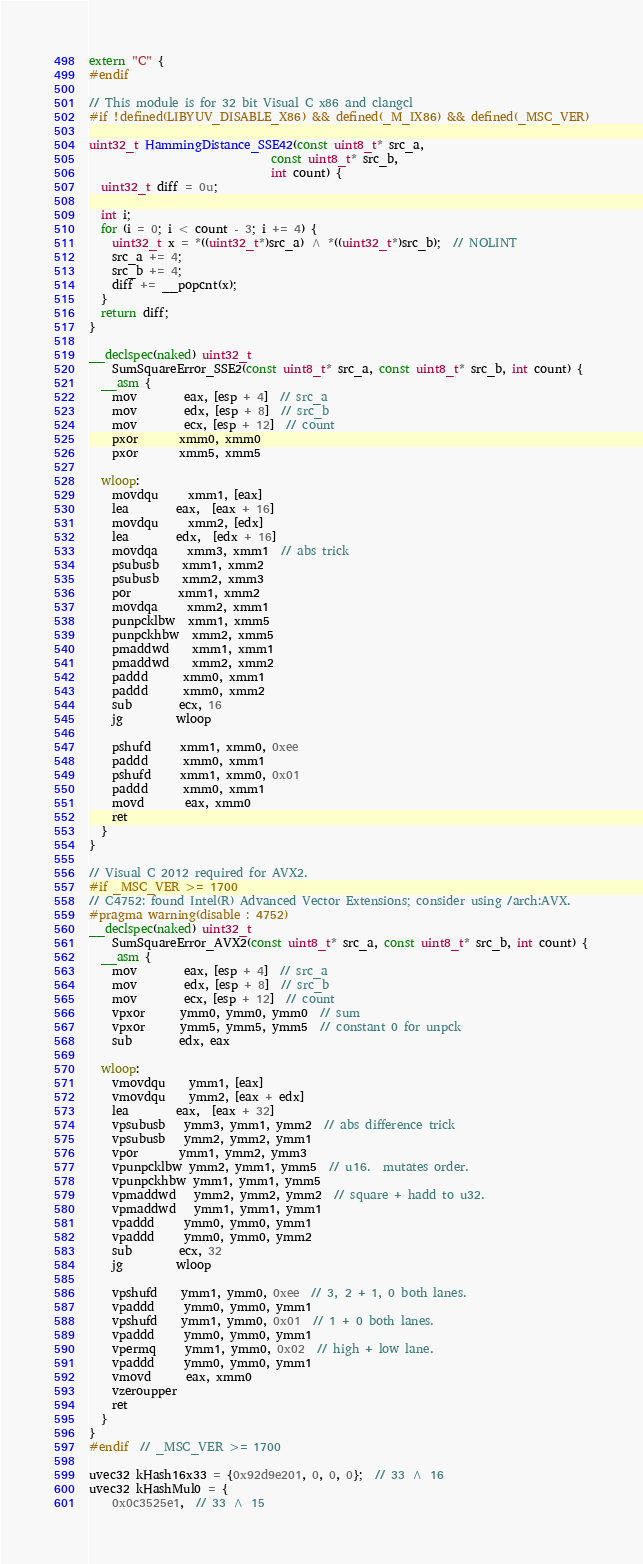Convert code to text. <code><loc_0><loc_0><loc_500><loc_500><_C_>extern "C" {
#endif

// This module is for 32 bit Visual C x86 and clangcl
#if !defined(LIBYUV_DISABLE_X86) && defined(_M_IX86) && defined(_MSC_VER)

uint32_t HammingDistance_SSE42(const uint8_t* src_a,
                               const uint8_t* src_b,
                               int count) {
  uint32_t diff = 0u;

  int i;
  for (i = 0; i < count - 3; i += 4) {
    uint32_t x = *((uint32_t*)src_a) ^ *((uint32_t*)src_b);  // NOLINT
    src_a += 4;
    src_b += 4;
    diff += __popcnt(x);
  }
  return diff;
}

__declspec(naked) uint32_t
    SumSquareError_SSE2(const uint8_t* src_a, const uint8_t* src_b, int count) {
  __asm {
    mov        eax, [esp + 4]  // src_a
    mov        edx, [esp + 8]  // src_b
    mov        ecx, [esp + 12]  // count
    pxor       xmm0, xmm0
    pxor       xmm5, xmm5

  wloop:
    movdqu     xmm1, [eax]
    lea        eax,  [eax + 16]
    movdqu     xmm2, [edx]
    lea        edx,  [edx + 16]
    movdqa     xmm3, xmm1  // abs trick
    psubusb    xmm1, xmm2
    psubusb    xmm2, xmm3
    por        xmm1, xmm2
    movdqa     xmm2, xmm1
    punpcklbw  xmm1, xmm5
    punpckhbw  xmm2, xmm5
    pmaddwd    xmm1, xmm1
    pmaddwd    xmm2, xmm2
    paddd      xmm0, xmm1
    paddd      xmm0, xmm2
    sub        ecx, 16
    jg         wloop

    pshufd     xmm1, xmm0, 0xee
    paddd      xmm0, xmm1
    pshufd     xmm1, xmm0, 0x01
    paddd      xmm0, xmm1
    movd       eax, xmm0
    ret
  }
}

// Visual C 2012 required for AVX2.
#if _MSC_VER >= 1700
// C4752: found Intel(R) Advanced Vector Extensions; consider using /arch:AVX.
#pragma warning(disable : 4752)
__declspec(naked) uint32_t
    SumSquareError_AVX2(const uint8_t* src_a, const uint8_t* src_b, int count) {
  __asm {
    mov        eax, [esp + 4]  // src_a
    mov        edx, [esp + 8]  // src_b
    mov        ecx, [esp + 12]  // count
    vpxor      ymm0, ymm0, ymm0  // sum
    vpxor      ymm5, ymm5, ymm5  // constant 0 for unpck
    sub        edx, eax

  wloop:
    vmovdqu    ymm1, [eax]
    vmovdqu    ymm2, [eax + edx]
    lea        eax,  [eax + 32]
    vpsubusb   ymm3, ymm1, ymm2  // abs difference trick
    vpsubusb   ymm2, ymm2, ymm1
    vpor       ymm1, ymm2, ymm3
    vpunpcklbw ymm2, ymm1, ymm5  // u16.  mutates order.
    vpunpckhbw ymm1, ymm1, ymm5
    vpmaddwd   ymm2, ymm2, ymm2  // square + hadd to u32.
    vpmaddwd   ymm1, ymm1, ymm1
    vpaddd     ymm0, ymm0, ymm1
    vpaddd     ymm0, ymm0, ymm2
    sub        ecx, 32
    jg         wloop

    vpshufd    ymm1, ymm0, 0xee  // 3, 2 + 1, 0 both lanes.
    vpaddd     ymm0, ymm0, ymm1
    vpshufd    ymm1, ymm0, 0x01  // 1 + 0 both lanes.
    vpaddd     ymm0, ymm0, ymm1
    vpermq     ymm1, ymm0, 0x02  // high + low lane.
    vpaddd     ymm0, ymm0, ymm1
    vmovd      eax, xmm0
    vzeroupper
    ret
  }
}
#endif  // _MSC_VER >= 1700

uvec32 kHash16x33 = {0x92d9e201, 0, 0, 0};  // 33 ^ 16
uvec32 kHashMul0 = {
    0x0c3525e1,  // 33 ^ 15</code> 